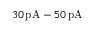Convert formula to latex. <formula><loc_0><loc_0><loc_500><loc_500>3 0 \, p A - 5 0 \, p A</formula> 